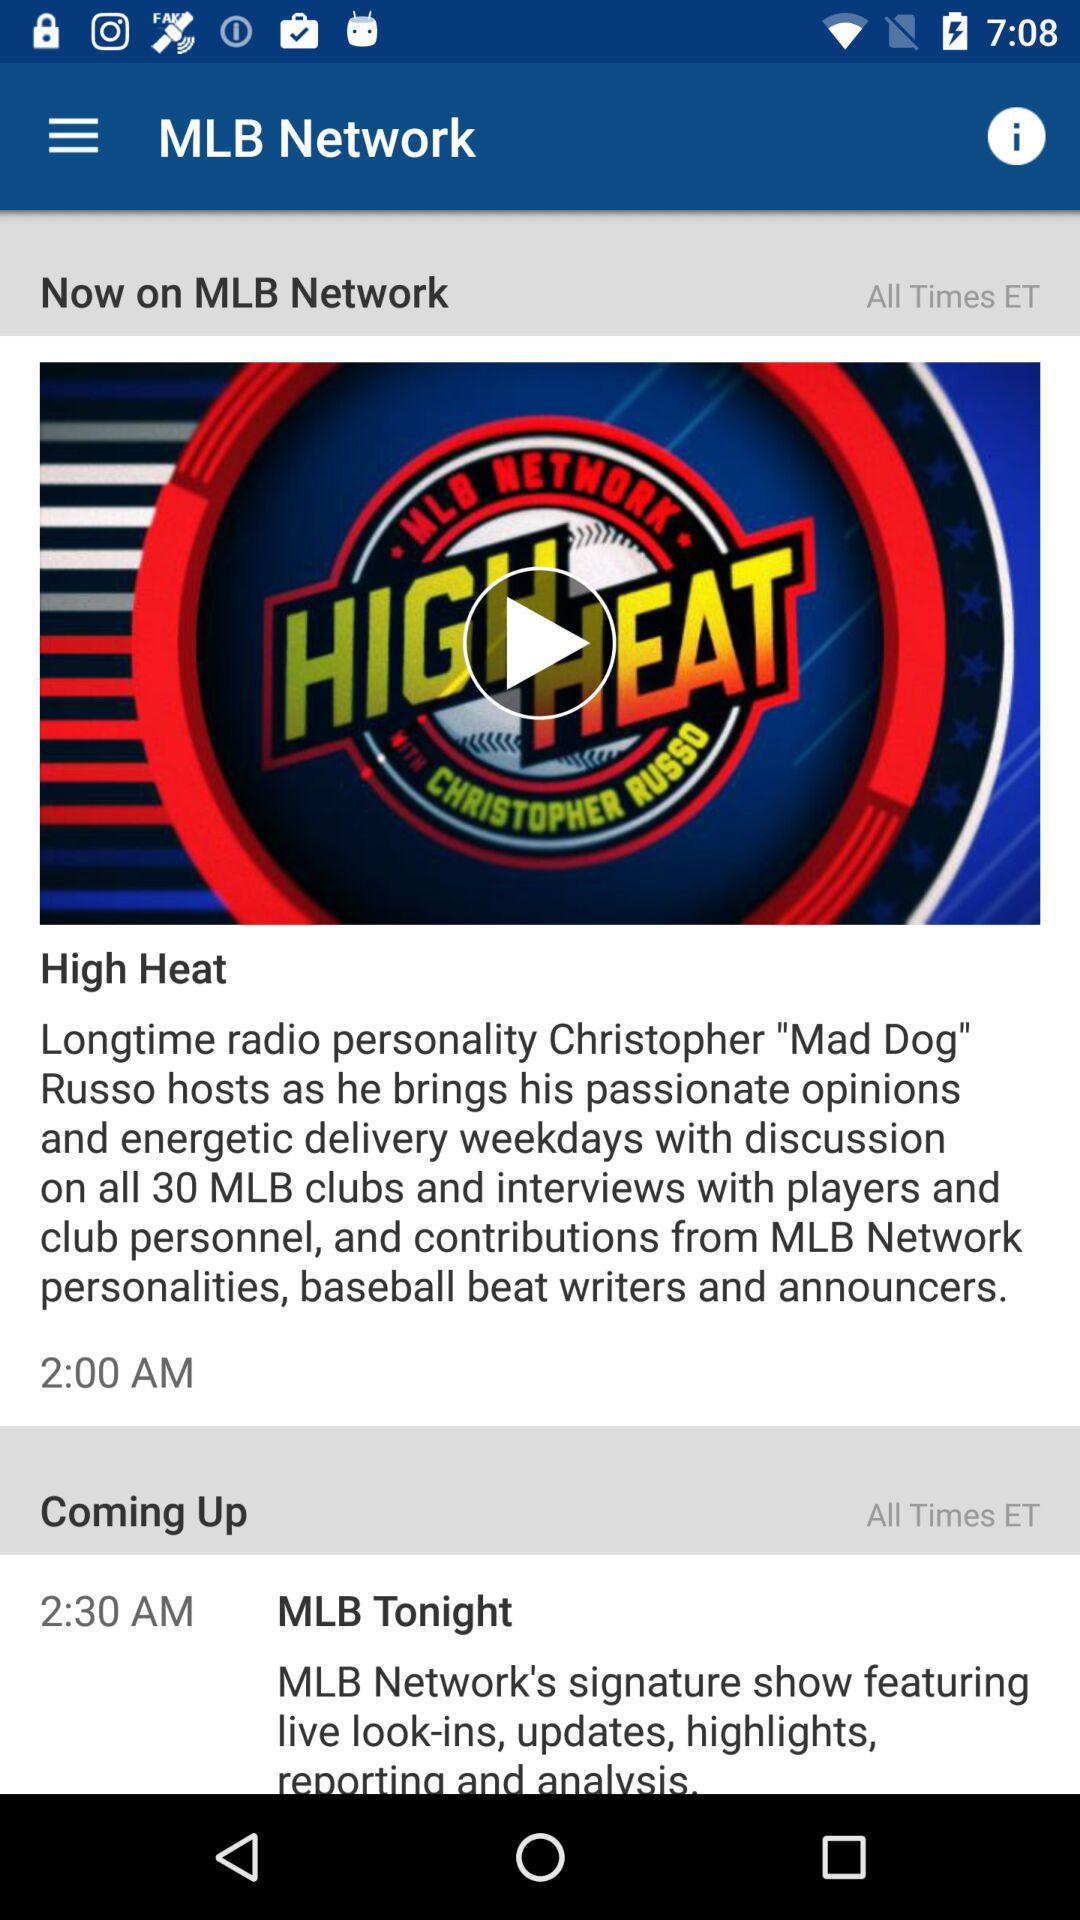What is the name of the upcoming show? The name of the upcoming show is "MLB Tonight". 